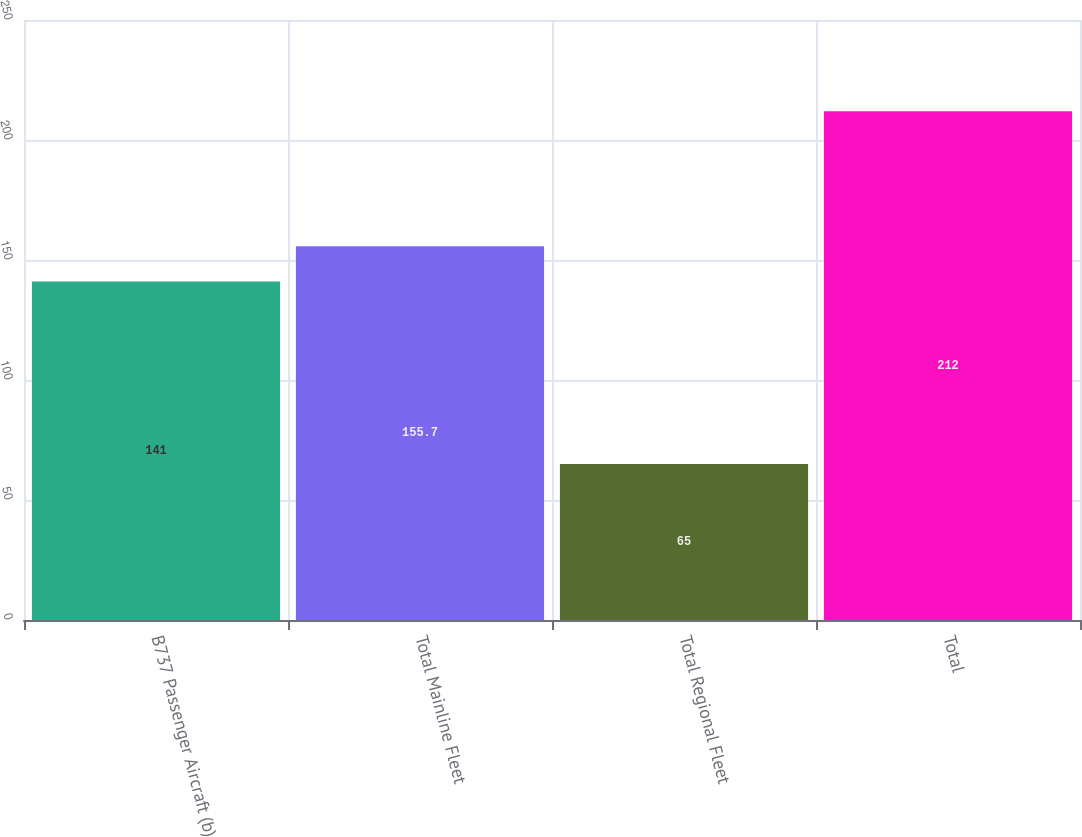Convert chart to OTSL. <chart><loc_0><loc_0><loc_500><loc_500><bar_chart><fcel>B737 Passenger Aircraft (b)<fcel>Total Mainline Fleet<fcel>Total Regional Fleet<fcel>Total<nl><fcel>141<fcel>155.7<fcel>65<fcel>212<nl></chart> 